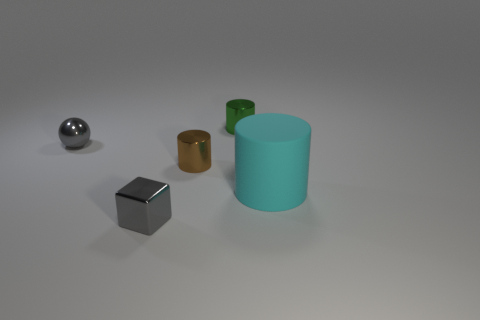What shape is the shiny object that is the same color as the ball?
Keep it short and to the point. Cube. How many other things are the same size as the cyan object?
Provide a succinct answer. 0. How many tiny things are either brown cylinders or green cylinders?
Your answer should be very brief. 2. Is the color of the tiny ball the same as the tiny shiny block?
Your answer should be very brief. Yes. Is the number of green cylinders that are to the left of the brown thing greater than the number of tiny metal cylinders in front of the tiny gray block?
Offer a terse response. No. There is a big cylinder right of the green cylinder; is its color the same as the metallic sphere?
Offer a terse response. No. Is there anything else of the same color as the big rubber cylinder?
Your answer should be compact. No. Is the number of tiny shiny things right of the small brown thing greater than the number of brown things?
Your response must be concise. No. Do the gray metallic block and the rubber thing have the same size?
Offer a terse response. No. What is the material of the large cyan object that is the same shape as the small brown thing?
Provide a short and direct response. Rubber. 